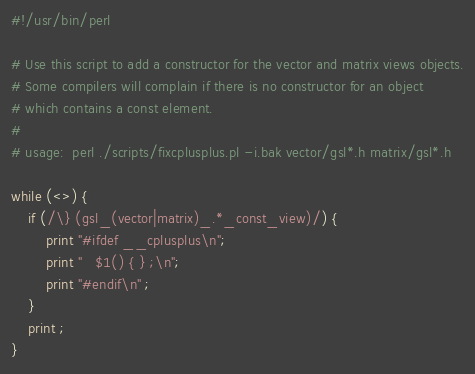<code> <loc_0><loc_0><loc_500><loc_500><_Perl_>#!/usr/bin/perl

# Use this script to add a constructor for the vector and matrix views objects.
# Some compilers will complain if there is no constructor for an object
# which contains a const element.
#
# usage:  perl ./scripts/fixcplusplus.pl -i.bak vector/gsl*.h matrix/gsl*.h

while (<>) {
    if (/\} (gsl_(vector|matrix)_.*_const_view)/) {
        print "#ifdef __cplusplus\n";
        print "   $1() { } ;\n";
        print "#endif\n" ;
    }
    print ;
}
</code> 